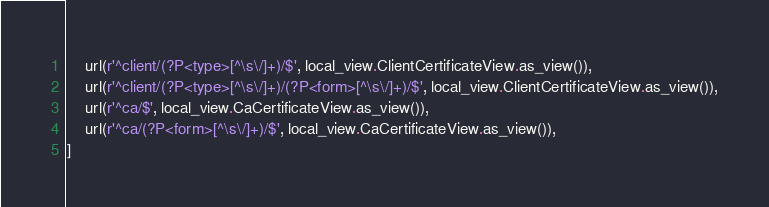Convert code to text. <code><loc_0><loc_0><loc_500><loc_500><_Python_>    url(r'^client/(?P<type>[^\s\/]+)/$', local_view.ClientCertificateView.as_view()),
    url(r'^client/(?P<type>[^\s\/]+)/(?P<form>[^\s\/]+)/$', local_view.ClientCertificateView.as_view()),
    url(r'^ca/$', local_view.CaCertificateView.as_view()),
    url(r'^ca/(?P<form>[^\s\/]+)/$', local_view.CaCertificateView.as_view()),
]
</code> 